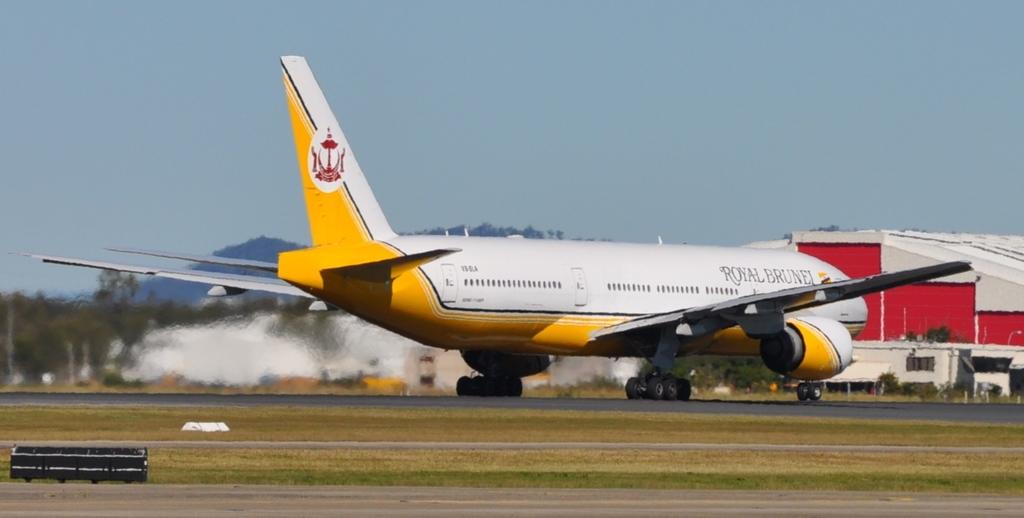What is the name on the yellow and white plane?
Ensure brevity in your answer.  Royal brunel. 